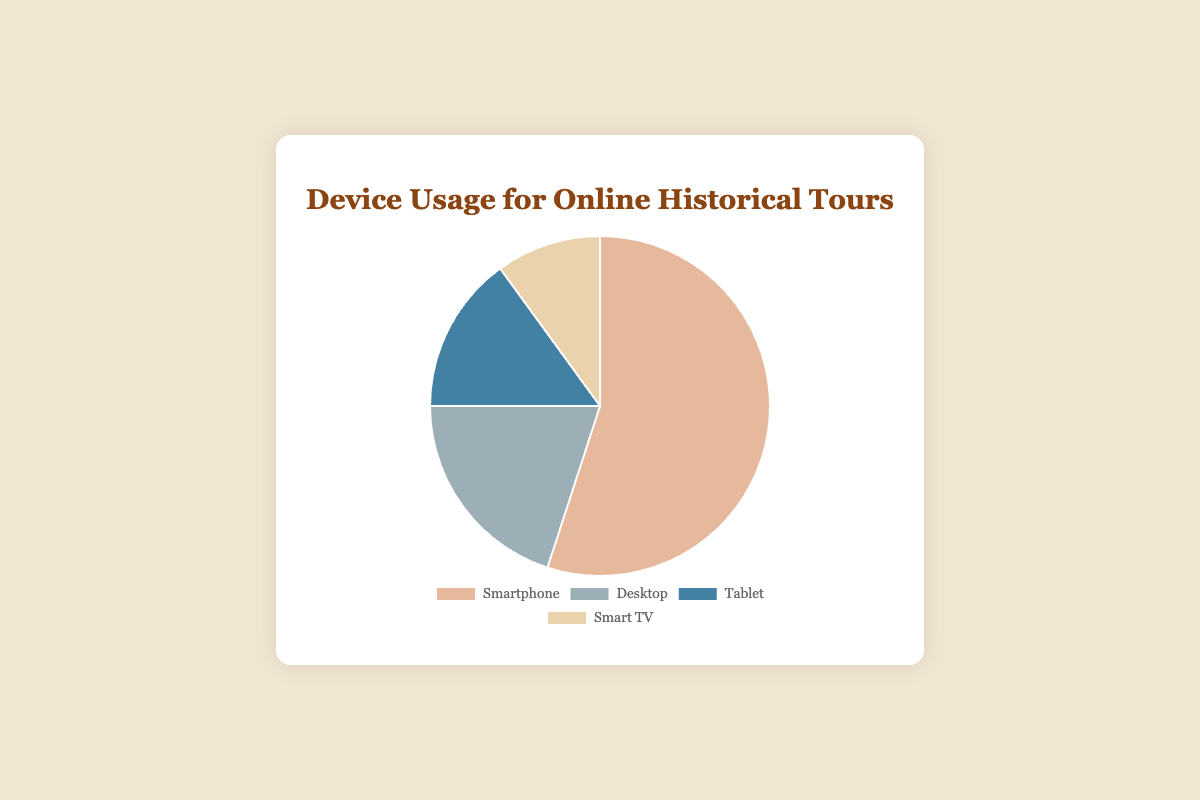Which device is the most commonly used for accessing online historical tours? The pie chart shows that smartphones have the largest portion, which is 55%. Smartphones hold the largest percentage.
Answer: Smartphones What is the combined percentage of users accessing tours via Desktop and Tablet? The pie chart shows Desktop at 20% and Tablet at 15%. Adding these percentages gives 20% + 15% = 35%.
Answer: 35% Which device has the smallest percentage of users accessing the tours? The pie chart indicates that Smart TV represents 10%, which is the smallest among all the devices listed.
Answer: Smart TV By how much does the percentage of Smartphone users exceed that of Desktop users? Smartphones account for 55%, while Desktops account for 20%. The difference is 55% - 20% = 35%.
Answer: 35% What fraction of users access the tours through either a Smartphone or a Smart TV? Adding the percentages for Smartphone (55%) and Smart TV (10%) gives 55% + 10% = 65%. This can be written as the fraction 65/100, which simplifies to 13/20.
Answer: 13/20 Is the percentage of Tablet users greater than that of Smart TV users, and if so, by how much? The percentage of Tablet users is 15%, and Smart TV users is 10%. Subtracting these gives 15% - 10% = 5%.
Answer: Yes, by 5% What is the average percentage of users accessing the tours via Smartphone, Tablet, and Smart TV? The pie chart shows the percentages as 55% for Smartphone, 15% for Tablet, and 10% for Smart TV. The average can be calculated as (55 + 15 + 10) / 3 = 80 / 3 ≈ 26.67%.
Answer: 26.67% What is the second most popular device for accessing the tours? The pie chart shows that the second largest percentage after Smartphone (55%) is Desktop, with 20%.
Answer: Desktop If we combine the percentages of Smartphones and Tablets, will they account for more than 70% of the user base? The percentage for Smartphones is 55%, and Tablet is 15%. Adding these gives 55% + 15% = 70%, which is exactly 70%.
Answer: No, it is exactly 70% What percentage of users access the tours via either a Desktop or a Tablet? The percentages for Desktops and Tablets are 20% and 15%, respectively. Adding these gives 20% + 15% = 35%.
Answer: 35% 